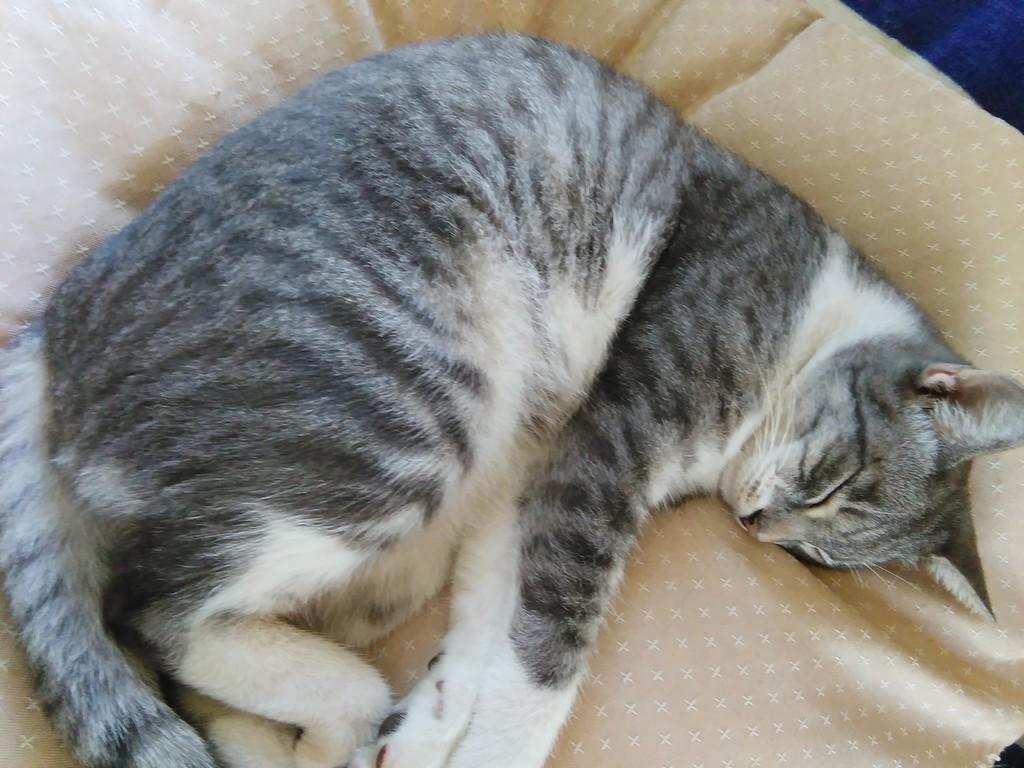What type of animal is present in the image? There is a cat in the image. Where is the cat located in the image? The cat is laying on a bed. Can you see any marks left by the cat on the bed in the image? There is no mention of any marks left by the cat on the bed in the image. 